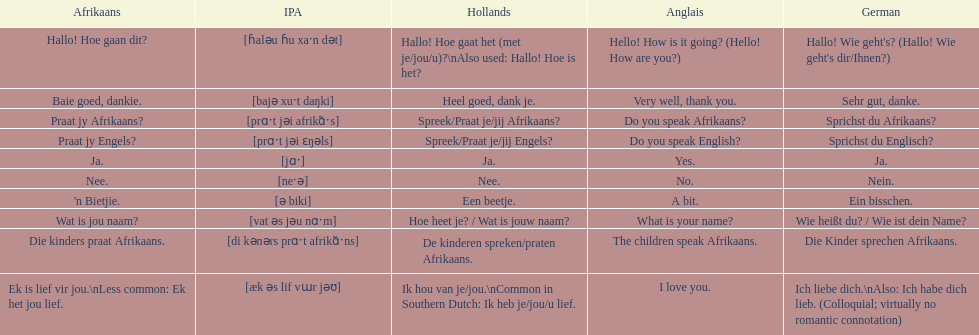How do you say 'yes' in afrikaans? Ja. 